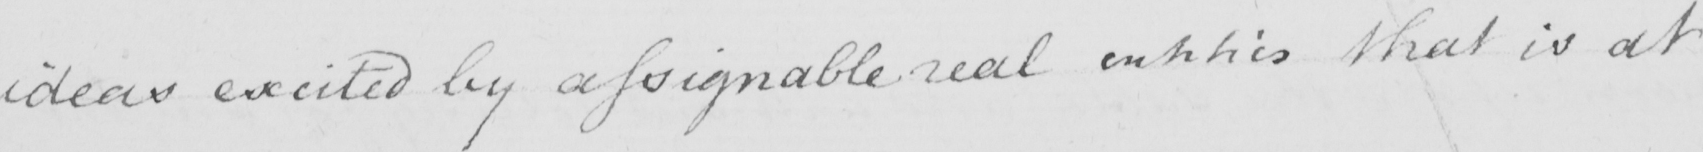What is written in this line of handwriting? ideas excited by assignable real entities that is at 